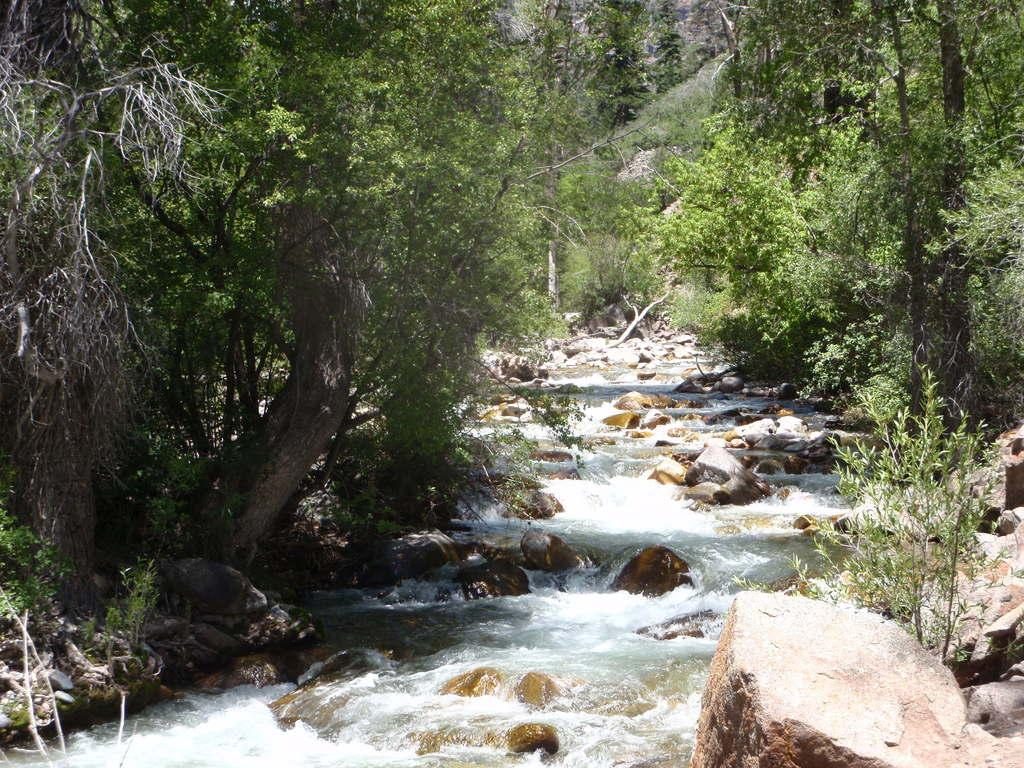What type of vegetation can be seen in the image? There are trees and plants in the image. What part of the trees can be seen in the image? There are branches in the image. What natural element is visible in the image? Water is visible in the image. What type of geological formation can be seen in the image? There are rocks in the image. What type of interest does the flesh have in the image? There is no flesh present in the image, so it is not possible to determine any interest. 